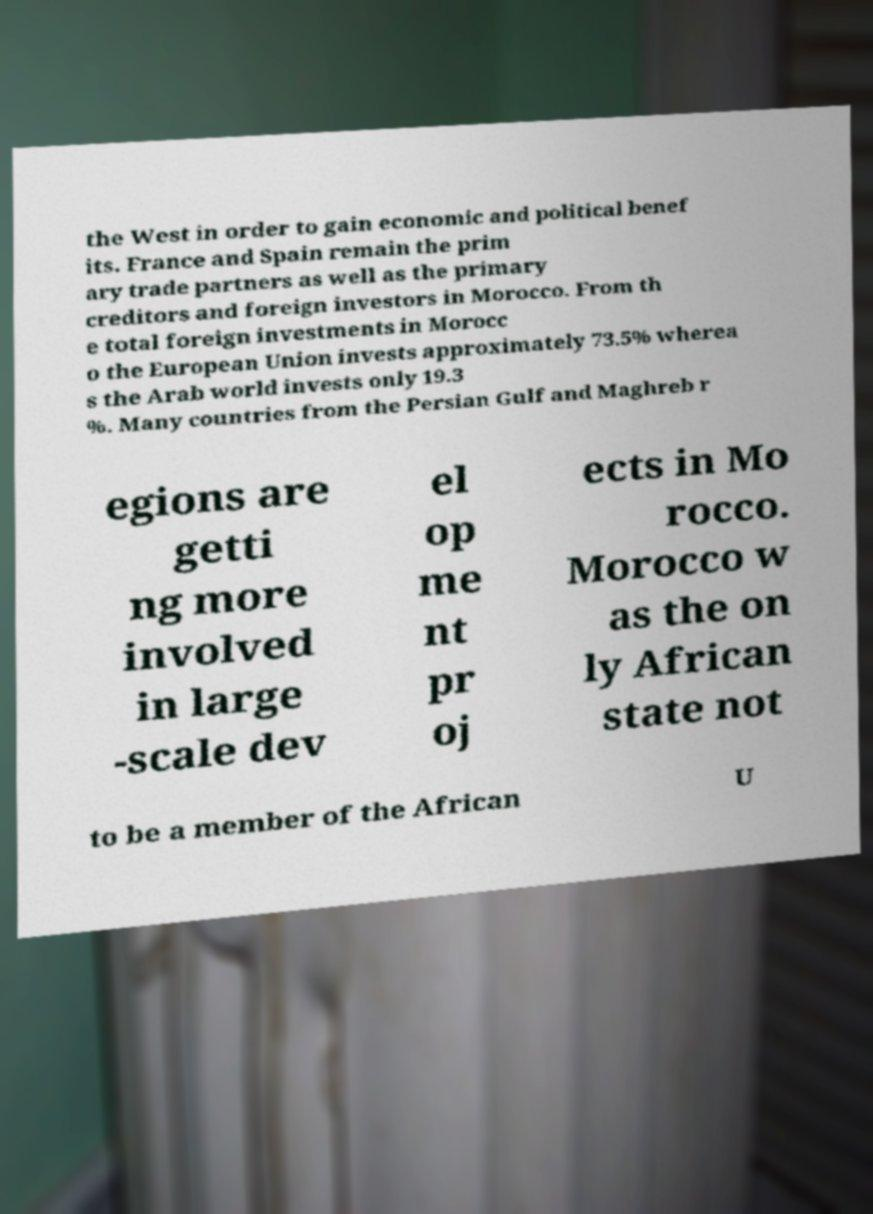There's text embedded in this image that I need extracted. Can you transcribe it verbatim? the West in order to gain economic and political benef its. France and Spain remain the prim ary trade partners as well as the primary creditors and foreign investors in Morocco. From th e total foreign investments in Morocc o the European Union invests approximately 73.5% wherea s the Arab world invests only 19.3 %. Many countries from the Persian Gulf and Maghreb r egions are getti ng more involved in large -scale dev el op me nt pr oj ects in Mo rocco. Morocco w as the on ly African state not to be a member of the African U 